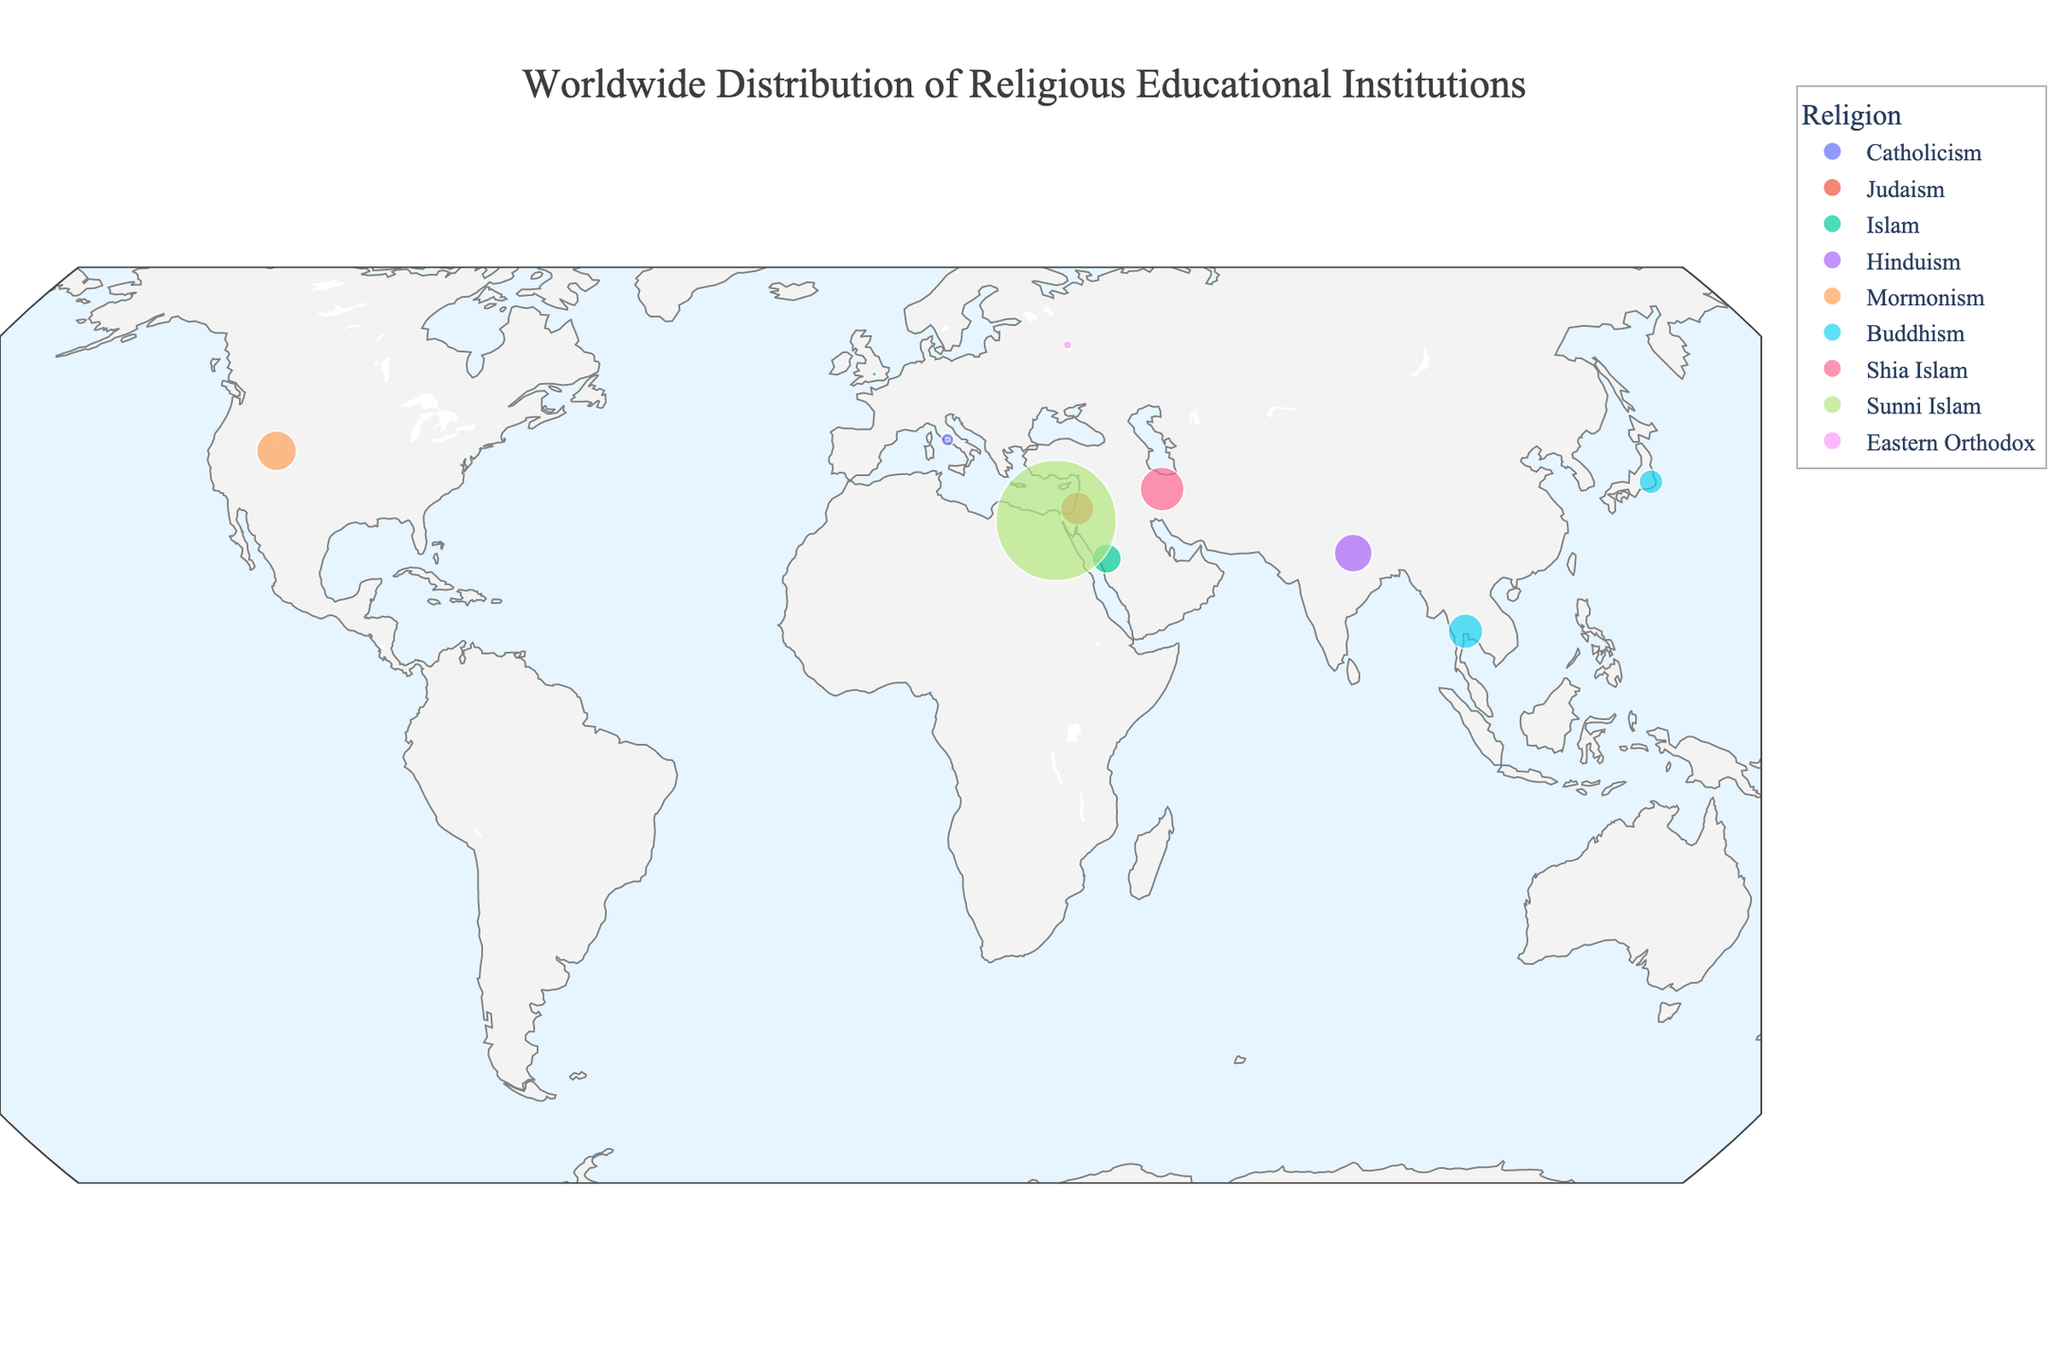What is the title of the figure? The title of the figure is displayed at the top and it provides a summary of what the plot represents.
Answer: Worldwide Distribution of Religious Educational Institutions Which country has the institution with the largest student population? From the sizes of the circles, we see that the largest circle is located in Egypt, indicating it has the institution with the largest student population.
Answer: Egypt Which institution represents Buddhism with the larger student population? There are two Buddhist institutions, Mahachulalongkornrajavidyalaya University in Thailand and Rissho University in Japan. By comparing the circle sizes, Mahachulalongkornrajavidyalaya University in Thailand has the larger student population.
Answer: Mahachulalongkornrajavidyalaya University How many educational institutions are represented for Islamic studies? By counting the circles color-coded for Islam (including Sunni and Shia), we find that there are four institutions: Islamic University of Madinah, Al-Mustafa International University, Oxford Centre for Islamic Studies, and Al-Azhar University.
Answer: 4 Compare the student populations of Pontifical Gregorian University and Brigham Young University. Which has more students? By comparing the circle sizes, Brigham Young University's circle is larger than Pontifical Gregorian University's, indicating it has a larger student population.
Answer: Brigham Young University What is the latitude and longitude of the institution with Catholicism having the smallest student population? Referring to the hover text, Pontifical Biblical Institute in Italy has the smallest student population among Catholic institutions. Its coordinates are shown at (41.8986, 12.4768).
Answer: (41.8986, 12.4768) Calculate the total student population represented in the figure. Summing student populations from all institutions: (3500 + 23000 + 18000 + 30000 + 33000 + 25000 + 40000 + 500 + 12000 + 300000 + 300 + 1500) results in a total of 486,800 students.
Answer: 486,800 Which institution has more students, the Hebrew University of Jerusalem or Banaras Hindu University? By comparing the circle sizes, Banaras Hindu University's circle is larger, indicating it has more students than the Hebrew University of Jerusalem.
Answer: Banaras Hindu University Determine the median student population across all religious educational institutions. First, arrange the student populations in ascending order: 300, 500, 1500, 3500, 12000, 18000, 23000, 25000, 30000, 33000, 40000, 300000. The median value is the middle number, which is 20,500.
Answer: 20,500 